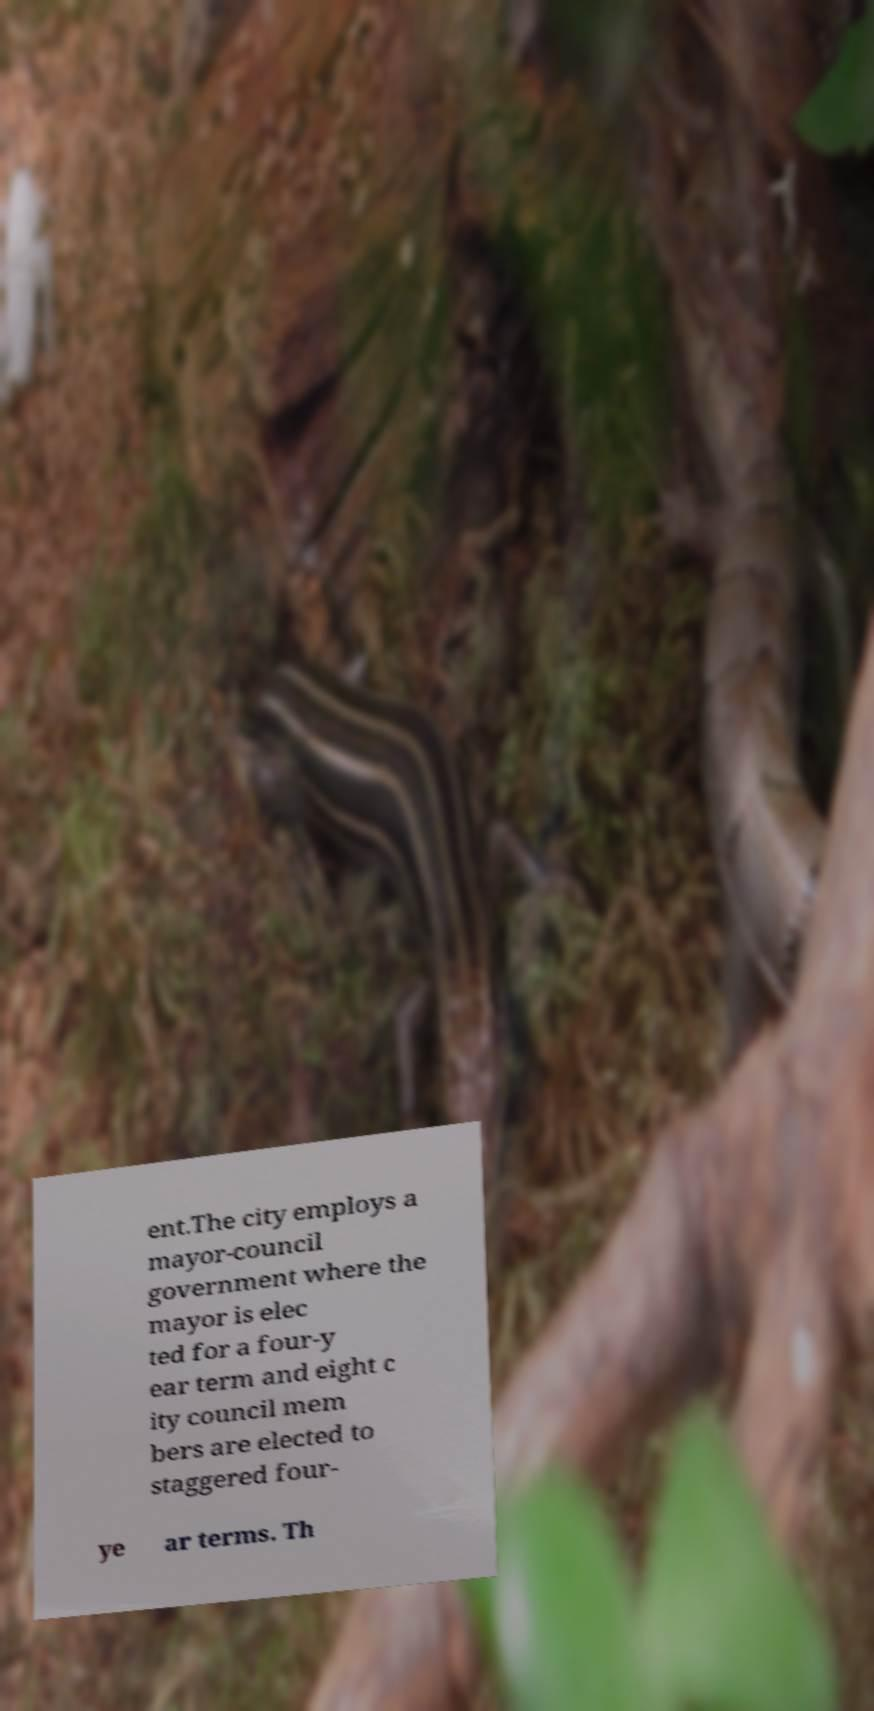Could you assist in decoding the text presented in this image and type it out clearly? ent.The city employs a mayor-council government where the mayor is elec ted for a four-y ear term and eight c ity council mem bers are elected to staggered four- ye ar terms. Th 